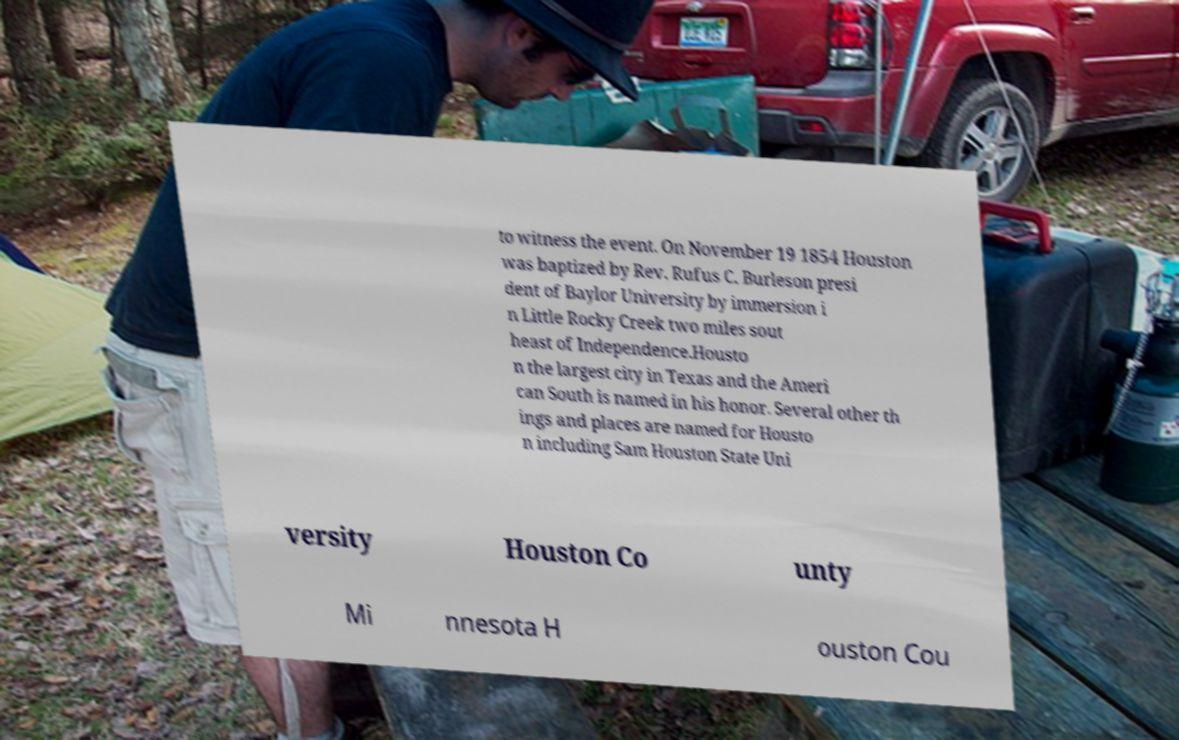Can you read and provide the text displayed in the image?This photo seems to have some interesting text. Can you extract and type it out for me? to witness the event. On November 19 1854 Houston was baptized by Rev. Rufus C. Burleson presi dent of Baylor University by immersion i n Little Rocky Creek two miles sout heast of Independence.Housto n the largest city in Texas and the Ameri can South is named in his honor. Several other th ings and places are named for Housto n including Sam Houston State Uni versity Houston Co unty Mi nnesota H ouston Cou 